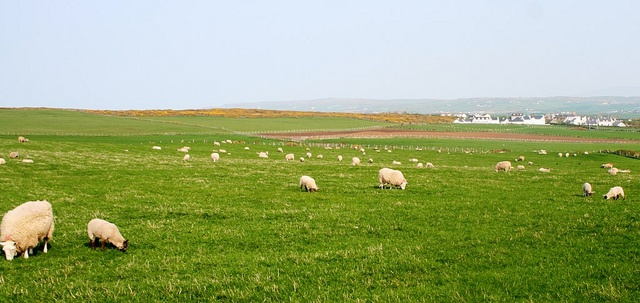Describe the objects in this image and their specific colors. I can see sheep in lavender and olive tones, sheep in lavender, tan, and beige tones, sheep in lavender, tan, and black tones, sheep in lavender, tan, beige, and olive tones, and sheep in lavender, tan, beige, and olive tones in this image. 